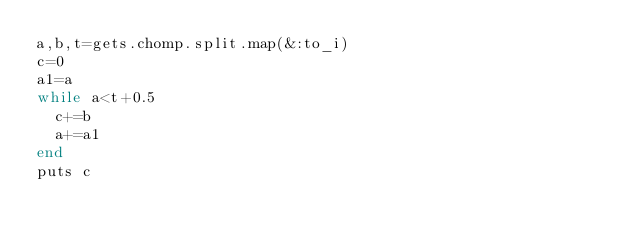Convert code to text. <code><loc_0><loc_0><loc_500><loc_500><_Ruby_>a,b,t=gets.chomp.split.map(&:to_i)
c=0
a1=a
while a<t+0.5
  c+=b
  a+=a1
end
puts c</code> 